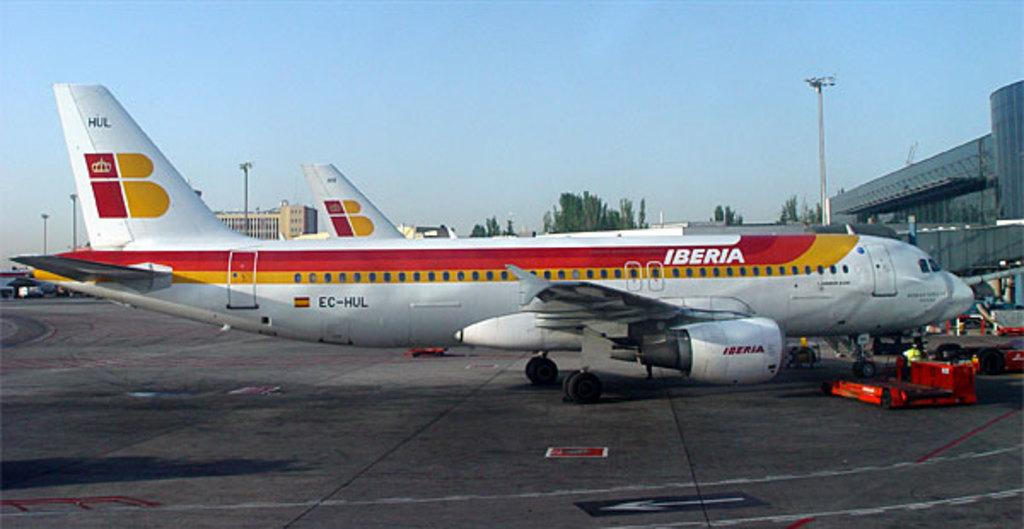<image>
Present a compact description of the photo's key features. A red, yellow and white IBERIA airplane sits at the terminal 